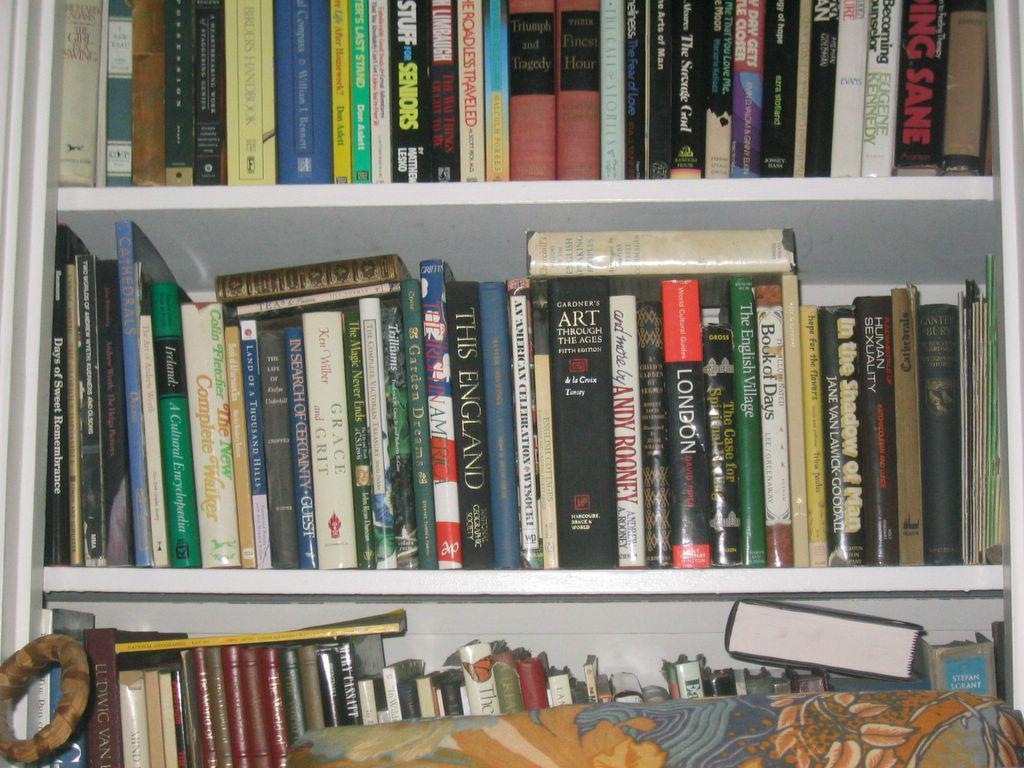What type of items can be seen in the image? There are books in a shelf in the image. Can you describe any other objects present in the image? There are some objects in the image, but their specific details are not mentioned in the provided facts. Can you tell me how many people are visible in the image? There is no person visible in the image; it only features books in a shelf and some unspecified objects. What type of tub is present in the image? There is no tub present in the image. 